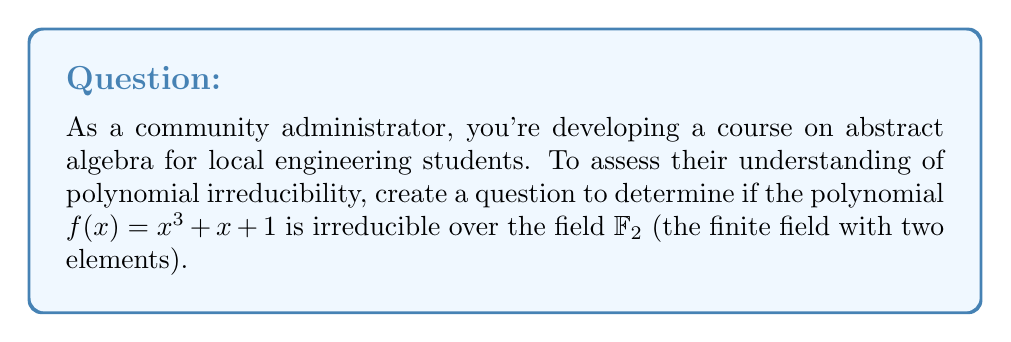What is the answer to this math problem? To determine if $f(x) = x^3 + x + 1$ is irreducible over $\mathbb{F}_2$, we need to check if it has any factors in $\mathbb{F}_2[x]$. We can do this systematically:

1) First, note that $\mathbb{F}_2 = \{0, 1\}$, so all coefficients and operations are modulo 2.

2) The polynomial is of degree 3, so it could only be reducible if it had a linear factor $(x + a)$ where $a \in \mathbb{F}_2$.

3) We can check this by evaluating $f(0)$ and $f(1)$:

   $f(0) = 0^3 + 0 + 1 = 1$
   $f(1) = 1^3 + 1 + 1 = 1 + 1 + 1 = 1$ (remember, we're in $\mathbb{F}_2$)

4) Since $f(0) \neq 0$ and $f(1) \neq 0$, the polynomial has no roots in $\mathbb{F}_2$.

5) Therefore, $f(x)$ has no linear factors in $\mathbb{F}_2[x]$.

6) Since $f(x)$ is of degree 3 and has no linear factors, it must be irreducible over $\mathbb{F}_2$.

This method of checking all possible roots is feasible for small finite fields but becomes impractical for larger fields or higher degree polynomials, where more advanced techniques are needed.
Answer: The polynomial $f(x) = x^3 + x + 1$ is irreducible over $\mathbb{F}_2$. 